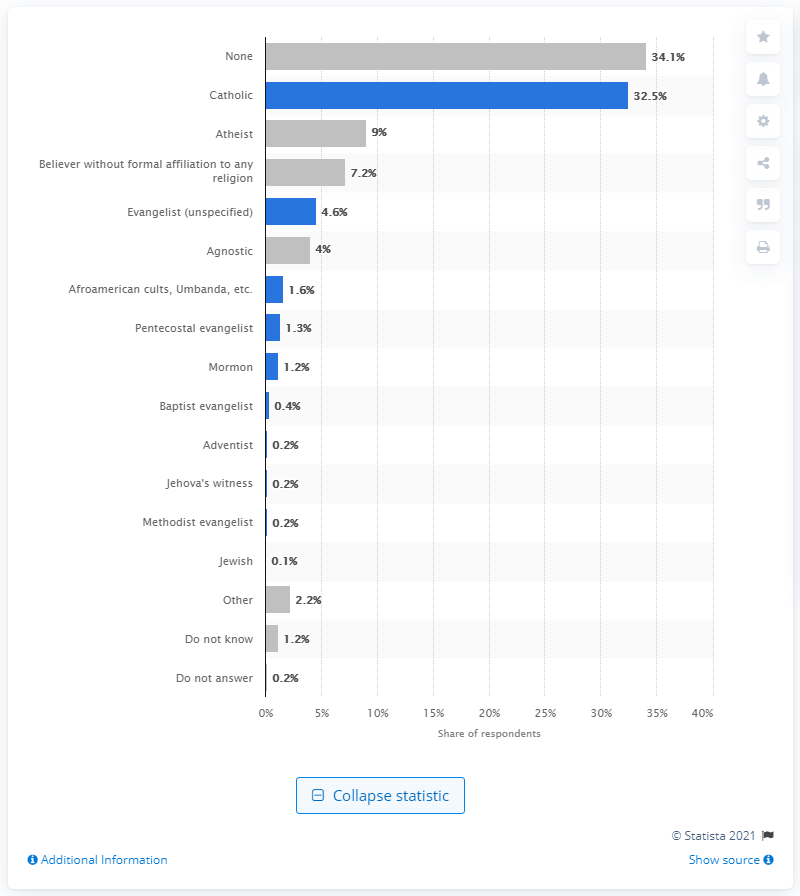Indicate a few pertinent items in this graphic. According to a survey, 34.1% of Uruguayans reported that they do not believe in any religion or spirituality. According to a survey conducted in July and August of 2018, 34.1% of Uruguayans reported having no religious affiliation. 